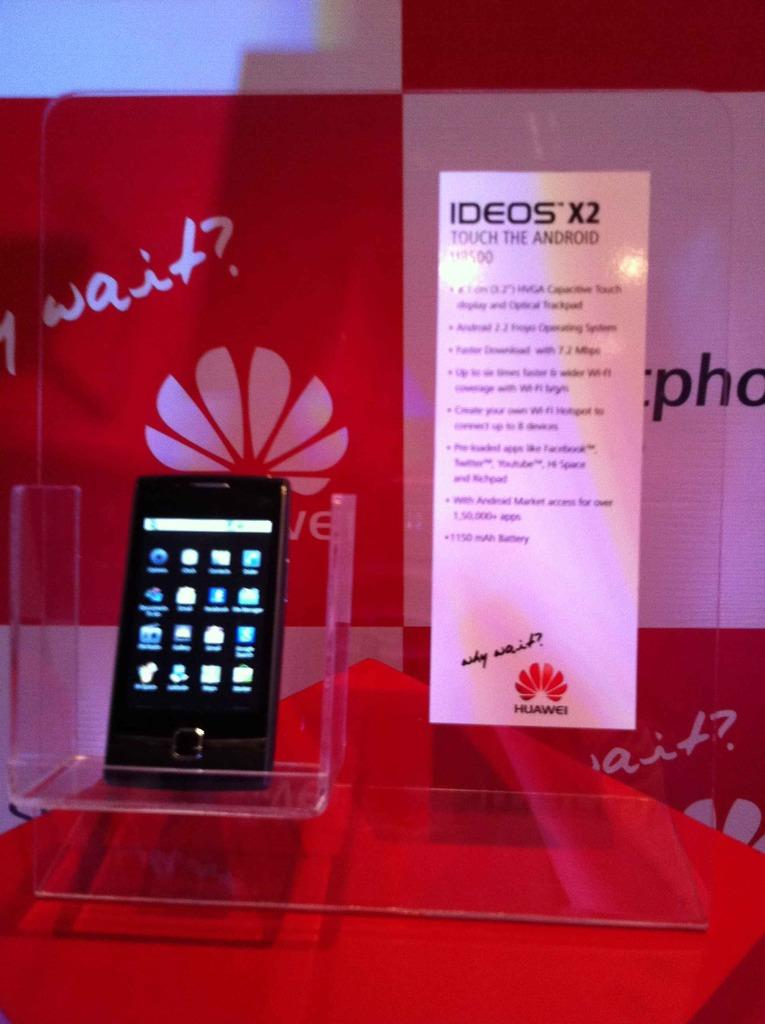<image>
Render a clear and concise summary of the photo. a phone next to a sign that says 'ideos x2' on it 